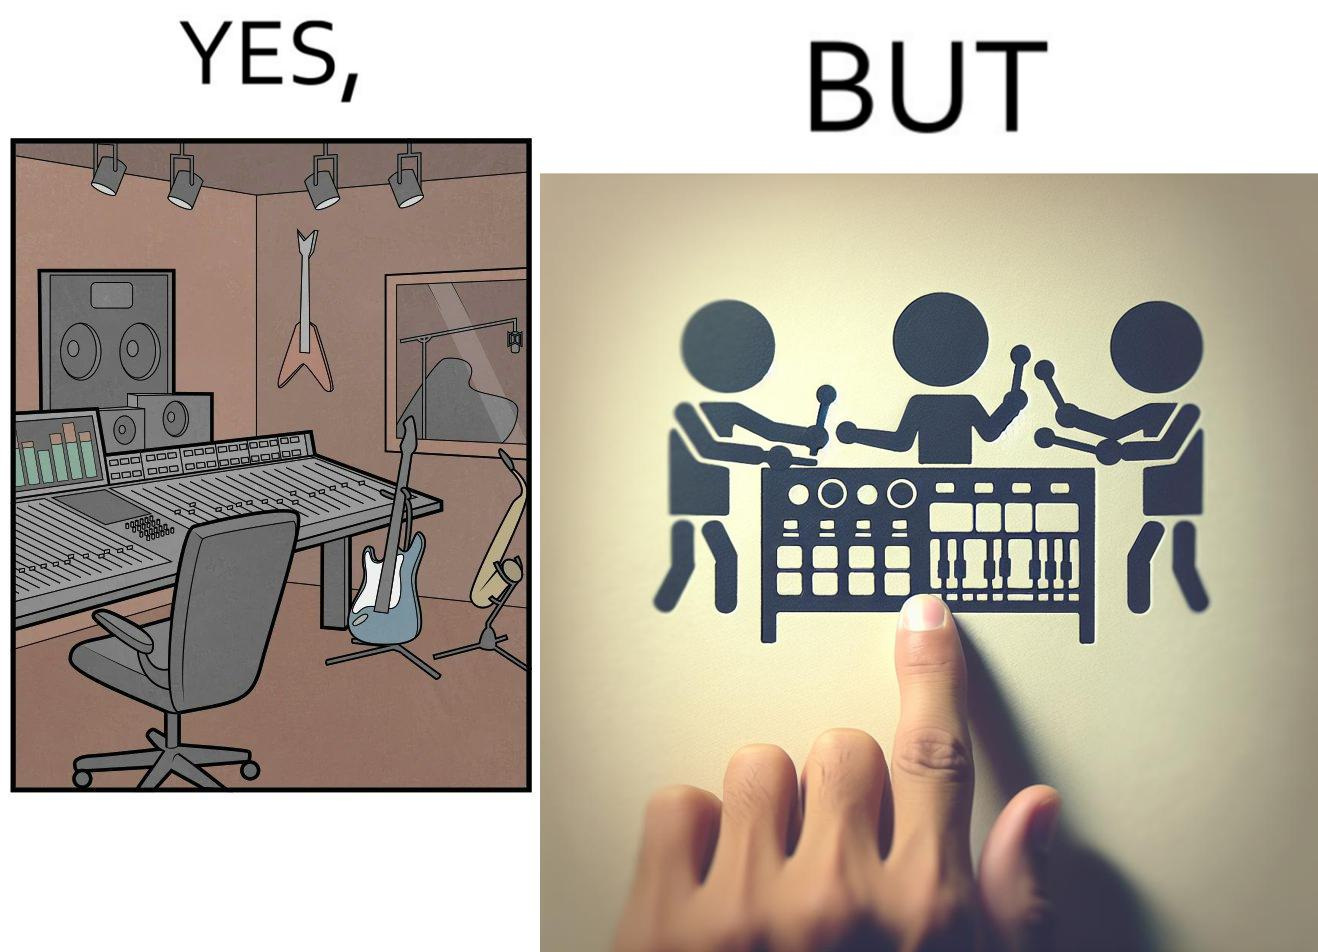Why is this image considered satirical? The image overall is funny because even though people have great music studios and instruments to create and record music, they use electronic replacements of the musical instruments to achieve the task. 